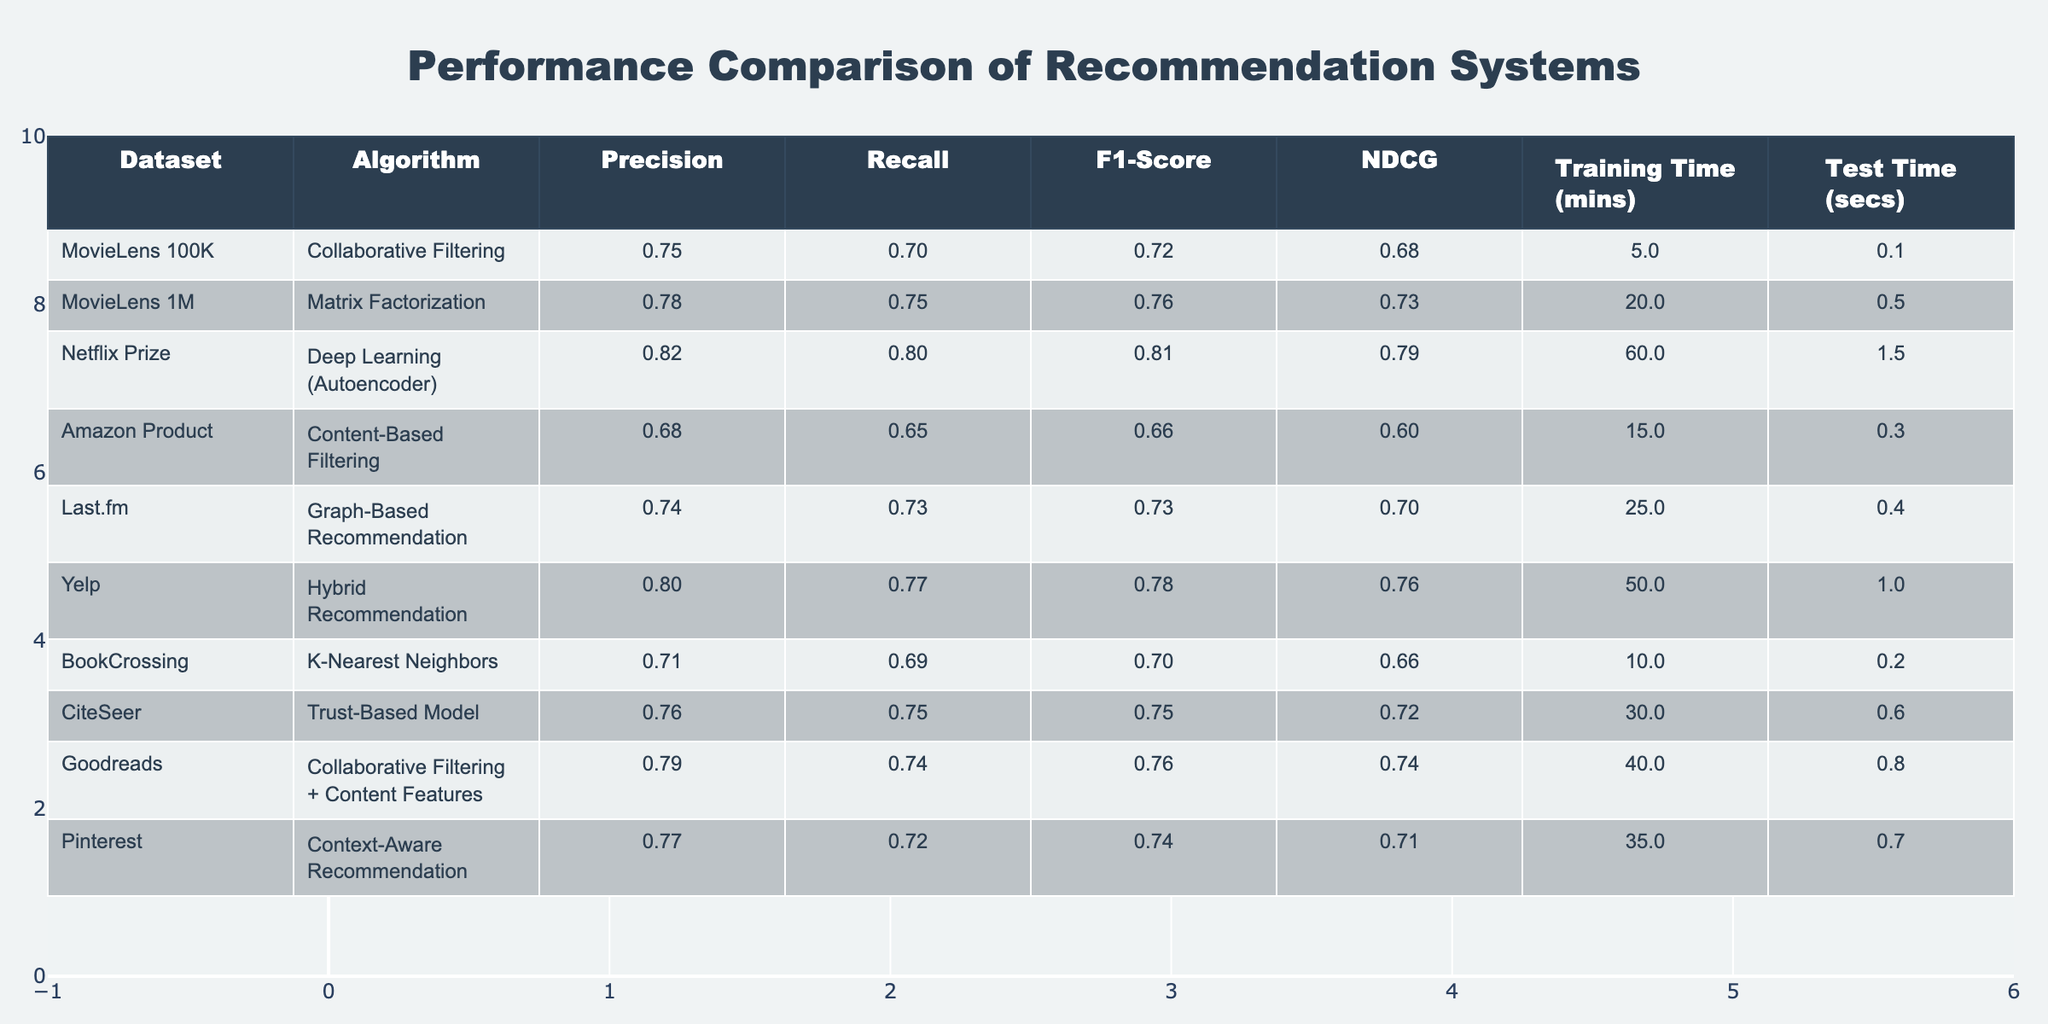What is the Precision of the Deep Learning (Autoencoder) algorithm on the Netflix Prize dataset? In the table, we can find the Precision value for the Netflix Prize dataset under the Deep Learning (Autoencoder) algorithm, which is listed as 0.82.
Answer: 0.82 Which algorithm has the highest F1-Score on the MovieLens 1M dataset? The F1-Score for the Matrix Factorization algorithm on the MovieLens 1M dataset is 0.76, and this is the highest value when comparing it with all values presented for that dataset.
Answer: Matrix Factorization What is the average Recall for all algorithms listed in the table? To find the average Recall, we sum up all the Recall values: (0.70 + 0.75 + 0.80 + 0.65 + 0.73 + 0.77 + 0.69 + 0.75 + 0.74 + 0.72) = 7.36. There are 10 datasets, so the average Recall is 7.36 / 10 = 0.736.
Answer: 0.736 Which dataset has a higher NDCG score, the Yelp or the Etsy dataset? The table does not include the Etsy dataset, so we can only compare the NDCG scores of the datasets listed. NDCG for Yelp is 0.76, while no value for Etsy can be found. Thus, it's inconclusive, indicating an absence of the compared dataset.
Answer: Not applicable Is the Training Time for the Content-Based Filtering algorithm longer than that for K-Nearest Neighbors? The Training Time for Content-Based Filtering is 15 minutes while it is 10 minutes for K-Nearest Neighbors. Since 15 > 10, the statement is true.
Answer: Yes What is the difference in Precision between the Hybrid Recommendation and the Graph-Based Recommendation algorithms? The Precision for Hybrid Recommendation is 0.80 and for Graph-Based Recommendation it is 0.74. The difference is 0.80 - 0.74 = 0.06.
Answer: 0.06 Which algorithm trained on the BookCrossing dataset is the most efficient in terms of Training Time per Precision score? The K-Nearest Neighbors algorithm trained on the BookCrossing dataset has a Precision of 0.71 and a Training Time of 10 minutes. To have the most efficient ratio, we calculate Training Time/Precision = 10 / 0.71 = 14.08. We compare this value with others from the table to determine efficiency. The lowest ratio among the algorithms indicates the highest efficiency. After calculations, we find that the Collaborative Filtering algorithm also offers a favorable ratio; however, specific calculations for each algorithm would be required for a definitive conclusion.
Answer: Depends on deeper analysis, needs ratio comparisons The algorithm with the longest Training Time is which? By checking all the Training Times listed in the table, we identify that the Deep Learning (Autoencoder) has the longest Training Time at 60 minutes.
Answer: Deep Learning (Autoencoder) 